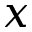Convert formula to latex. <formula><loc_0><loc_0><loc_500><loc_500>x</formula> 